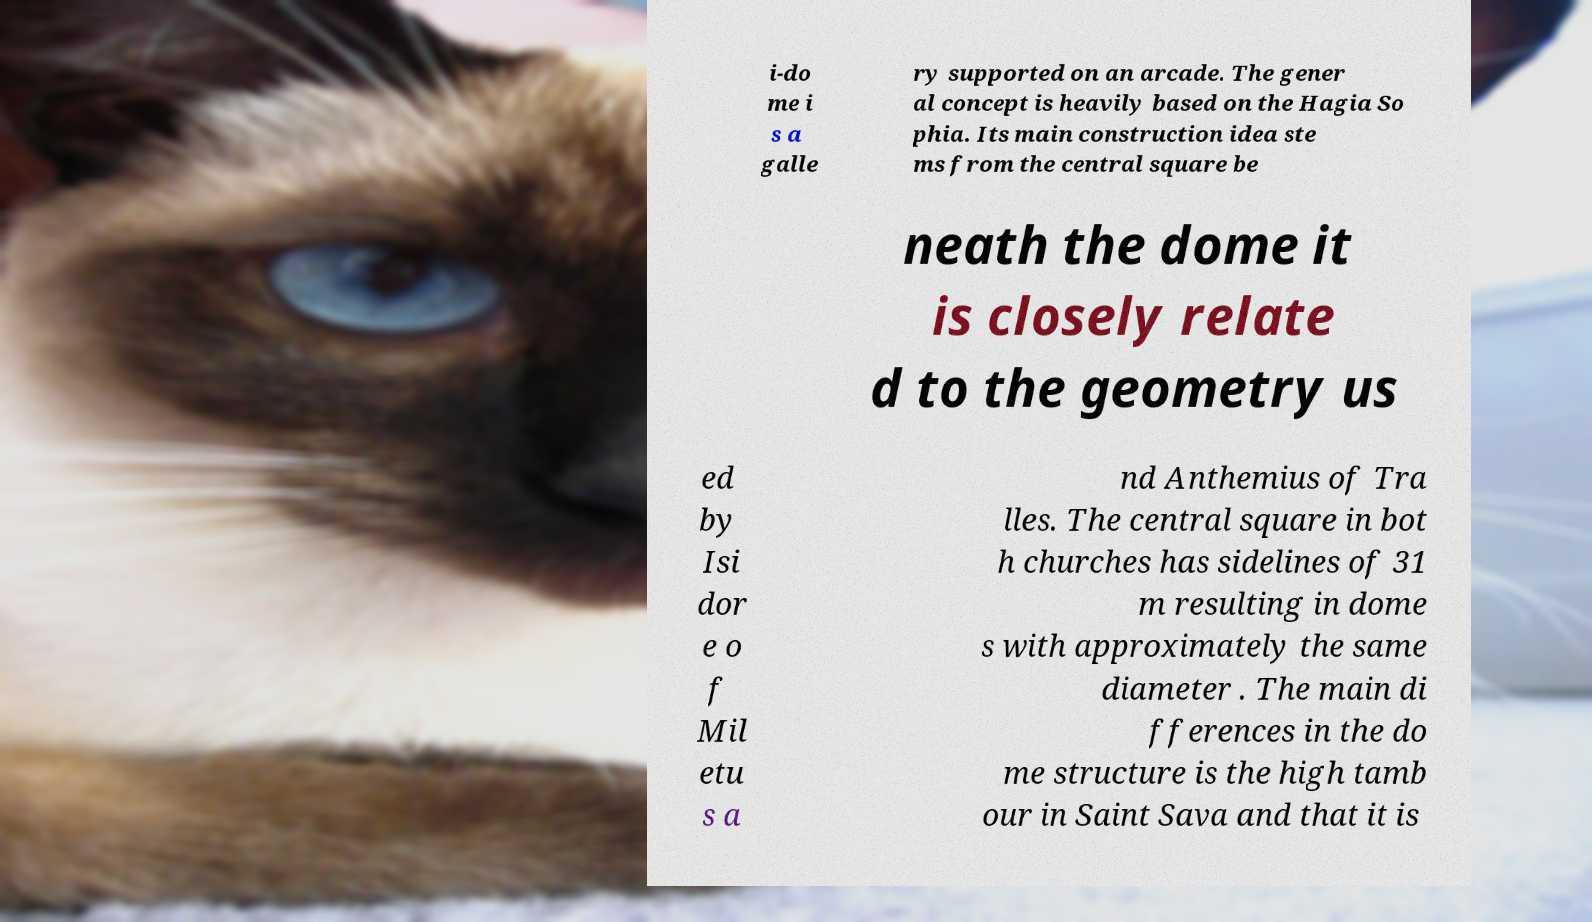I need the written content from this picture converted into text. Can you do that? i-do me i s a galle ry supported on an arcade. The gener al concept is heavily based on the Hagia So phia. Its main construction idea ste ms from the central square be neath the dome it is closely relate d to the geometry us ed by Isi dor e o f Mil etu s a nd Anthemius of Tra lles. The central square in bot h churches has sidelines of 31 m resulting in dome s with approximately the same diameter . The main di fferences in the do me structure is the high tamb our in Saint Sava and that it is 